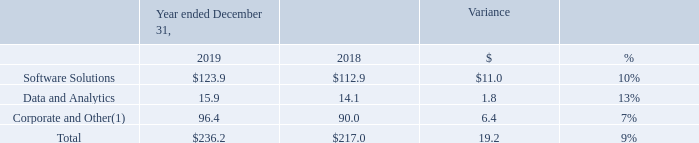Depreciation and Amortization
The following table sets forth depreciation and amortization by segment for the periods presented (in millions):
(1) Depreciation and amortization for Corporate and Other primarily represents net incremental depreciation and amortization adjustments associated with the application of purchase accounting recorded in accordance with GAAP.
The increase in Depreciation and Amortization is primarily driven by implementation of new clients, accelerated amortization of deferred contract costs and hardware and software placed in service.
Why did Depreciation and Amortization increase? Implementation of new clients, accelerated amortization of deferred contract costs and hardware and software placed in service. Which years does the table provide information for depreciation and amortization by segment? 2019, 2018. What was the dollar variance for Data and Analytics?
Answer scale should be: million. 1.8. What was the difference in the percent variance between Software Solutions and Data and Analytics?
Answer scale should be: percent. 13-10
Answer: 3. What was the average depreciation and amortization for Software Solutions between 2018 and 2019?
Answer scale should be: million. (123.9+112.9)/2
Answer: 118.4. What was the average total depreciation and amortization between 2018 and 2019?
Answer scale should be: million. (236.2+217.0)/2
Answer: 226.6. 